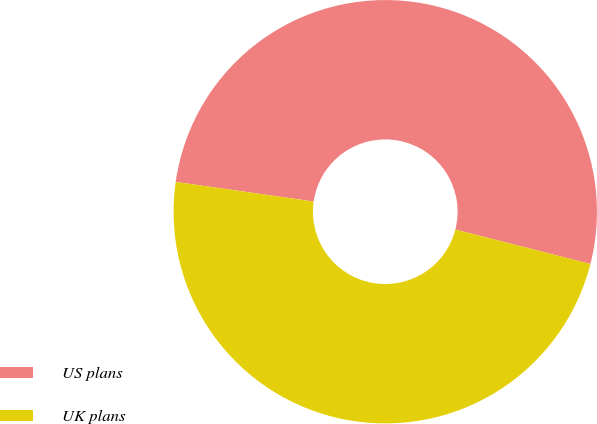<chart> <loc_0><loc_0><loc_500><loc_500><pie_chart><fcel>US plans<fcel>UK plans<nl><fcel>51.72%<fcel>48.28%<nl></chart> 